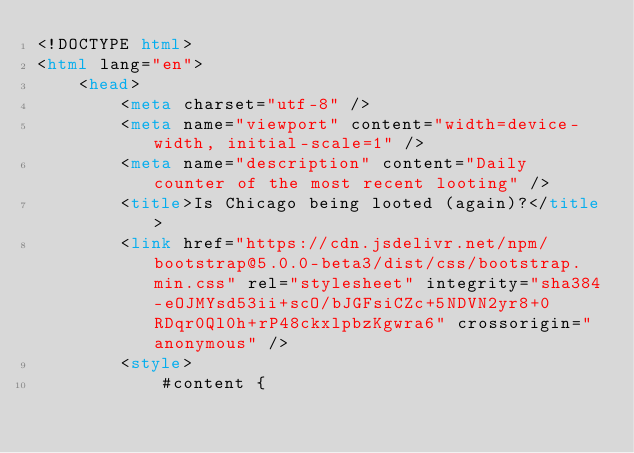<code> <loc_0><loc_0><loc_500><loc_500><_HTML_><!DOCTYPE html>
<html lang="en">
    <head>
        <meta charset="utf-8" />
        <meta name="viewport" content="width=device-width, initial-scale=1" />
        <meta name="description" content="Daily counter of the most recent looting" />
        <title>Is Chicago being looted (again)?</title>
        <link href="https://cdn.jsdelivr.net/npm/bootstrap@5.0.0-beta3/dist/css/bootstrap.min.css" rel="stylesheet" integrity="sha384-eOJMYsd53ii+scO/bJGFsiCZc+5NDVN2yr8+0RDqr0Ql0h+rP48ckxlpbzKgwra6" crossorigin="anonymous" />
        <style>
            #content {</code> 